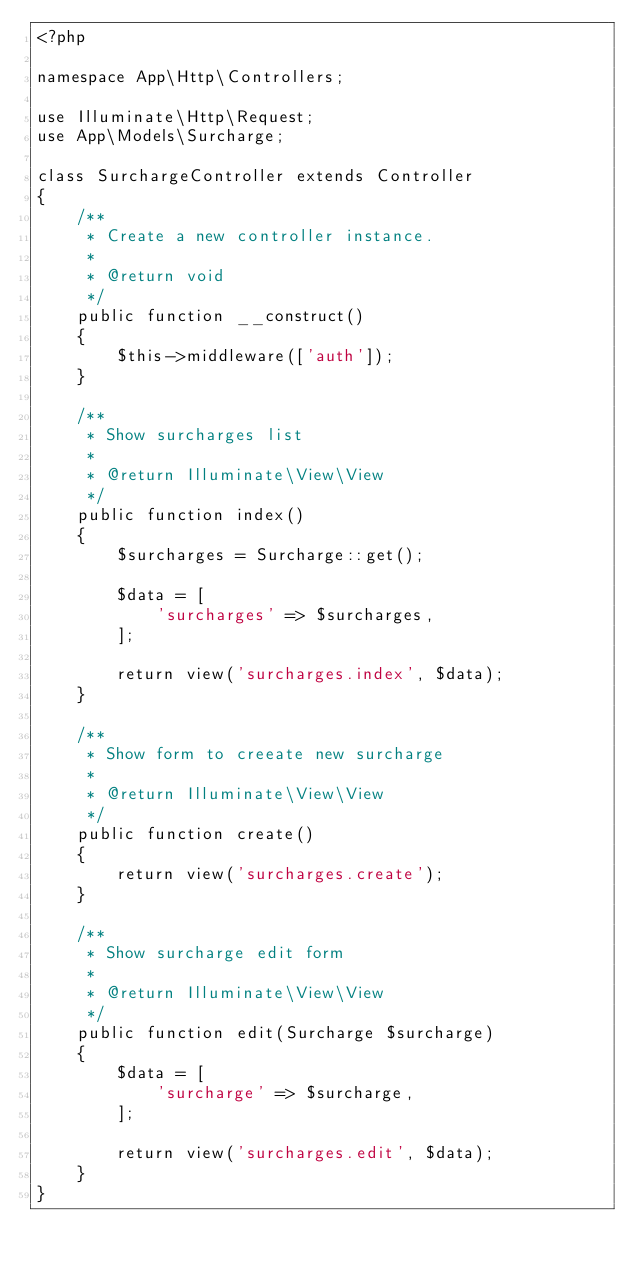Convert code to text. <code><loc_0><loc_0><loc_500><loc_500><_PHP_><?php

namespace App\Http\Controllers;

use Illuminate\Http\Request;
use App\Models\Surcharge;

class SurchargeController extends Controller
{
    /**
     * Create a new controller instance.
     *
     * @return void
     */
    public function __construct()
    {
        $this->middleware(['auth']);
    }

    /**
     * Show surcharges list
     *
     * @return Illuminate\View\View
     */
    public function index()
    {
        $surcharges = Surcharge::get();

        $data = [
            'surcharges' => $surcharges,
        ];

        return view('surcharges.index', $data);
    }

    /**
     * Show form to creeate new surcharge
     *
     * @return Illuminate\View\View
     */
    public function create()
    {
        return view('surcharges.create');
    }

    /**
     * Show surcharge edit form
     *
     * @return Illuminate\View\View
     */
    public function edit(Surcharge $surcharge)
    {
        $data = [
            'surcharge' => $surcharge,
        ];

        return view('surcharges.edit', $data);
    }
}
</code> 